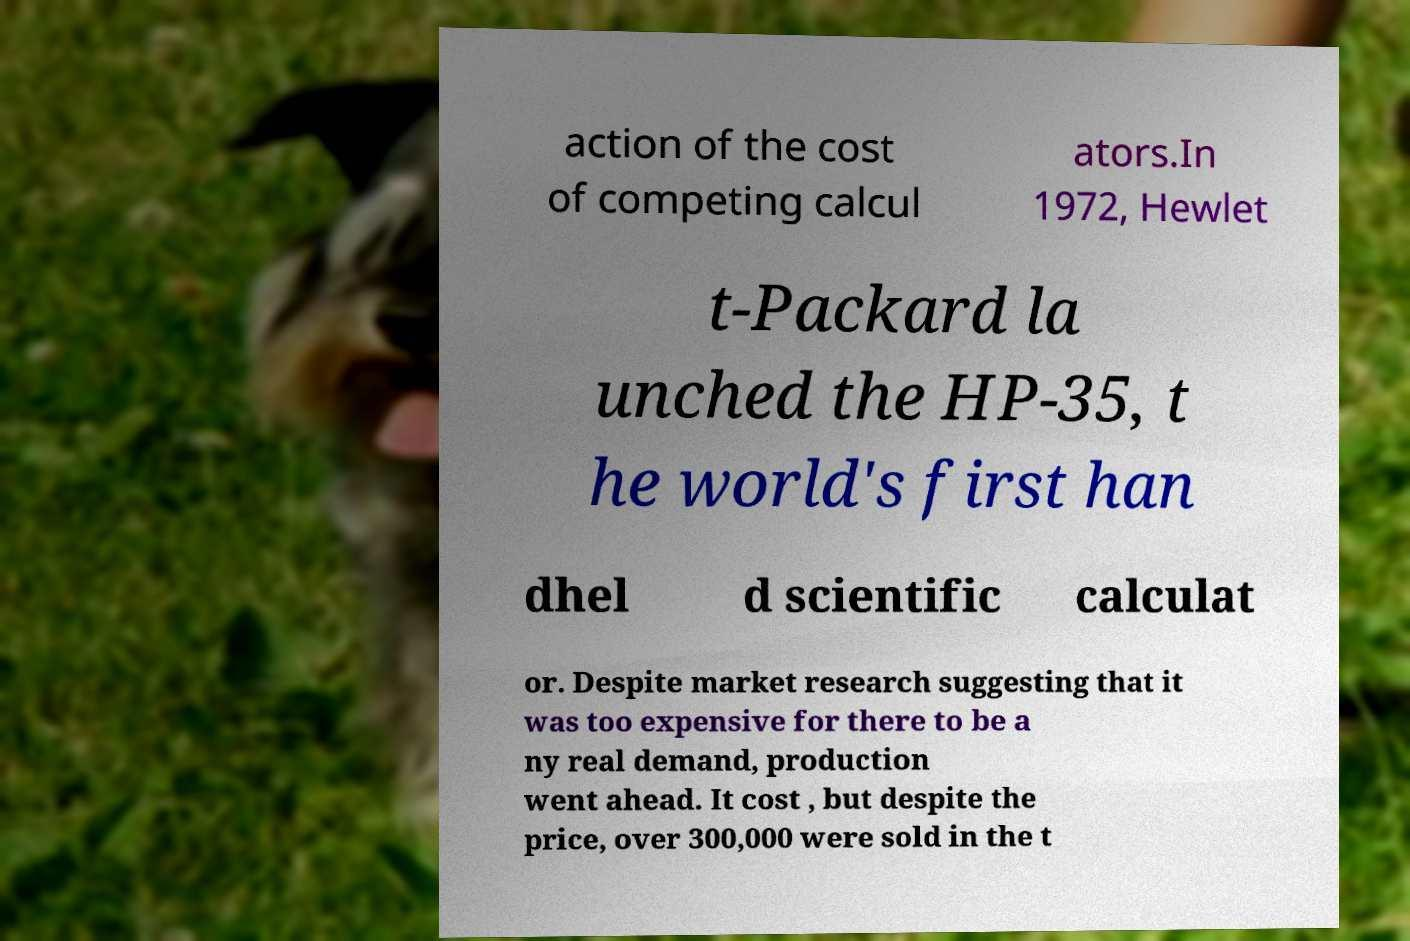What messages or text are displayed in this image? I need them in a readable, typed format. action of the cost of competing calcul ators.In 1972, Hewlet t-Packard la unched the HP-35, t he world's first han dhel d scientific calculat or. Despite market research suggesting that it was too expensive for there to be a ny real demand, production went ahead. It cost , but despite the price, over 300,000 were sold in the t 